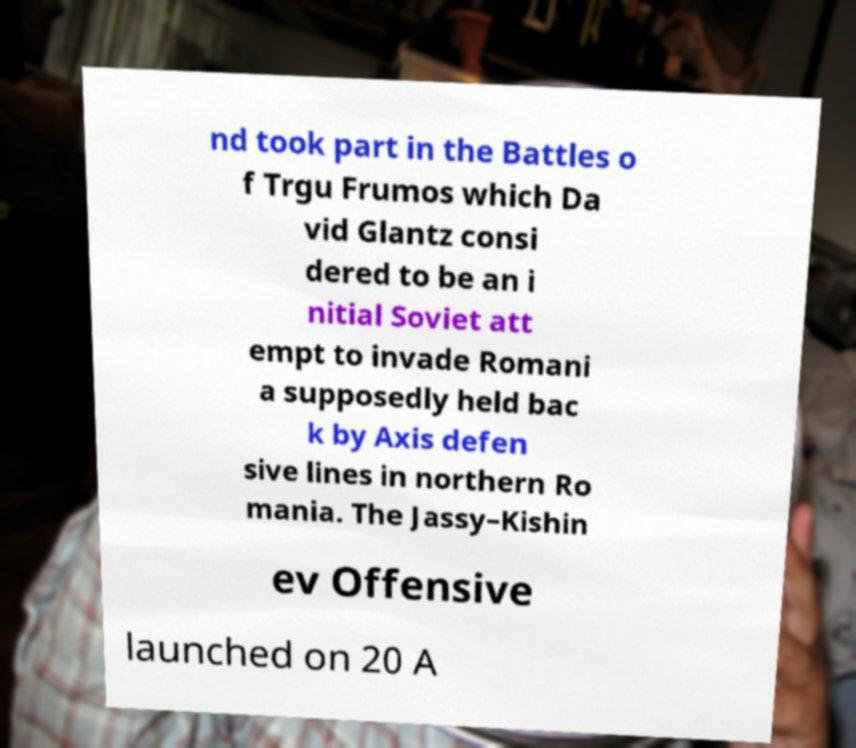Can you accurately transcribe the text from the provided image for me? nd took part in the Battles o f Trgu Frumos which Da vid Glantz consi dered to be an i nitial Soviet att empt to invade Romani a supposedly held bac k by Axis defen sive lines in northern Ro mania. The Jassy–Kishin ev Offensive launched on 20 A 